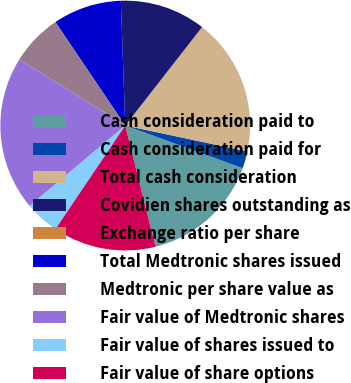<chart> <loc_0><loc_0><loc_500><loc_500><pie_chart><fcel>Cash consideration paid to<fcel>Cash consideration paid for<fcel>Total cash consideration<fcel>Covidien shares outstanding as<fcel>Exchange ratio per share<fcel>Total Medtronic shares issued<fcel>Medtronic per share value as<fcel>Fair value of Medtronic shares<fcel>Fair value of shares issued to<fcel>Fair value of share options<nl><fcel>15.56%<fcel>2.22%<fcel>17.78%<fcel>11.11%<fcel>0.0%<fcel>8.89%<fcel>6.67%<fcel>20.0%<fcel>4.44%<fcel>13.33%<nl></chart> 